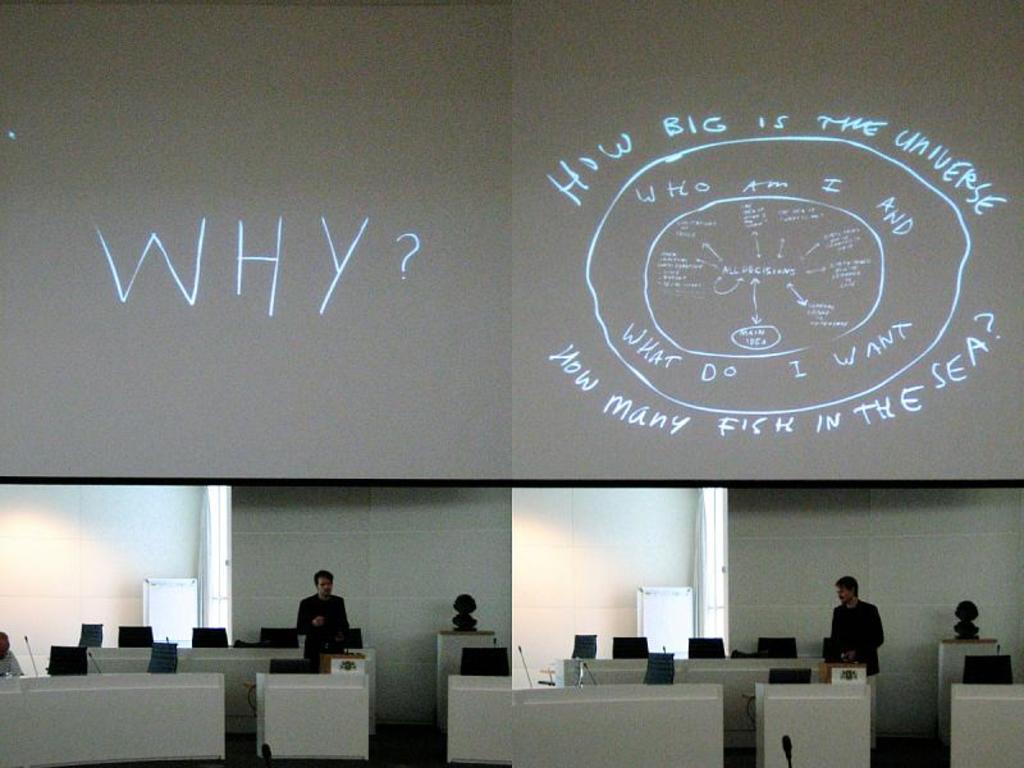Describe this image in one or two sentences. In this image I can see few people and I can see they are wearing black dress. I can also see number of chairs and mics. In the background I can see something is written. 